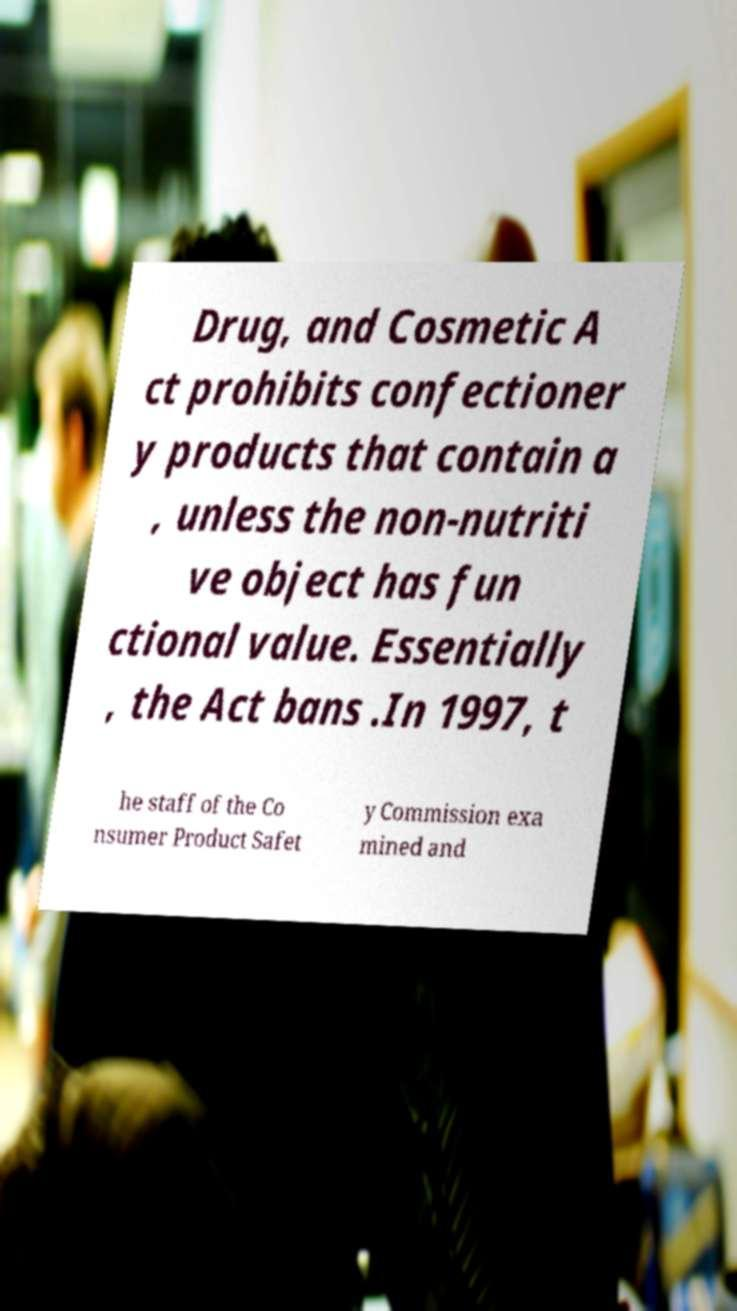Please identify and transcribe the text found in this image. Drug, and Cosmetic A ct prohibits confectioner y products that contain a , unless the non-nutriti ve object has fun ctional value. Essentially , the Act bans .In 1997, t he staff of the Co nsumer Product Safet y Commission exa mined and 